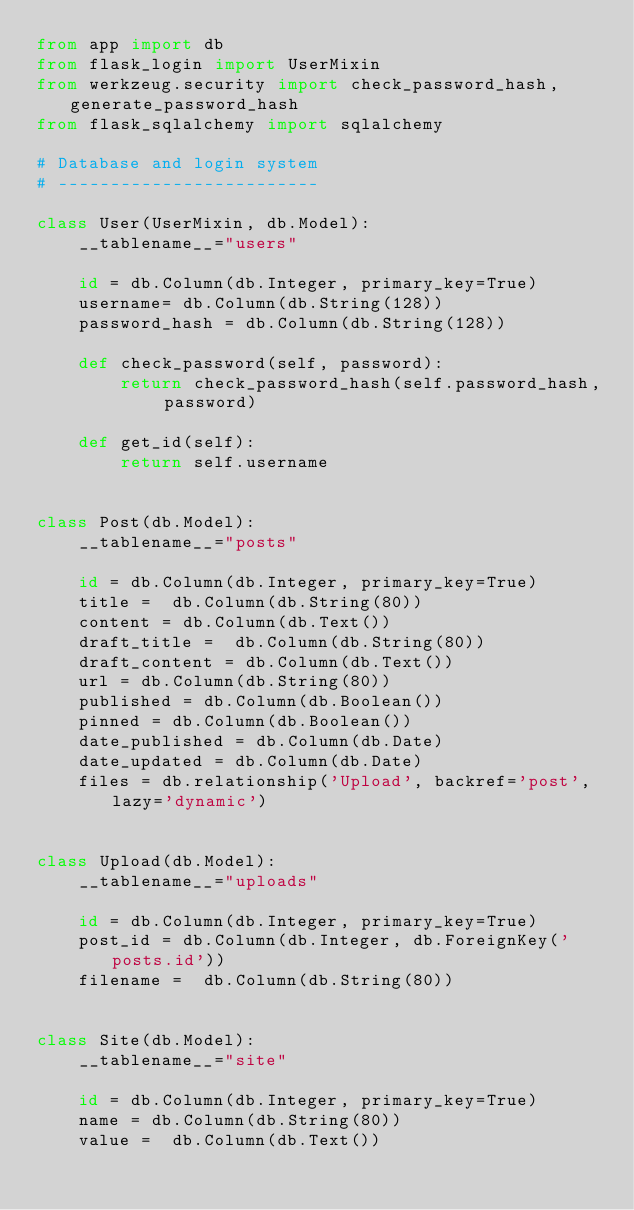Convert code to text. <code><loc_0><loc_0><loc_500><loc_500><_Python_>from app import db
from flask_login import UserMixin
from werkzeug.security import check_password_hash, generate_password_hash
from flask_sqlalchemy import sqlalchemy

# Database and login system 
# -------------------------

class User(UserMixin, db.Model):
    __tablename__="users"
    
    id = db.Column(db.Integer, primary_key=True)
    username= db.Column(db.String(128))
    password_hash = db.Column(db.String(128))
    
    def check_password(self, password):
        return check_password_hash(self.password_hash, password)
        
    def get_id(self):
        return self.username
    
        
class Post(db.Model):
    __tablename__="posts"
    
    id = db.Column(db.Integer, primary_key=True)
    title =  db.Column(db.String(80))
    content = db.Column(db.Text())
    draft_title =  db.Column(db.String(80))
    draft_content = db.Column(db.Text())
    url = db.Column(db.String(80))
    published = db.Column(db.Boolean())
    pinned = db.Column(db.Boolean())
    date_published = db.Column(db.Date)
    date_updated = db.Column(db.Date)
    files = db.relationship('Upload', backref='post', lazy='dynamic')
    
    
class Upload(db.Model):
    __tablename__="uploads"
    
    id = db.Column(db.Integer, primary_key=True)
    post_id = db.Column(db.Integer, db.ForeignKey('posts.id'))
    filename =  db.Column(db.String(80))


class Site(db.Model):
    __tablename__="site"
    
    id = db.Column(db.Integer, primary_key=True) 
    name = db.Column(db.String(80))
    value =  db.Column(db.Text())
    
    
    
</code> 